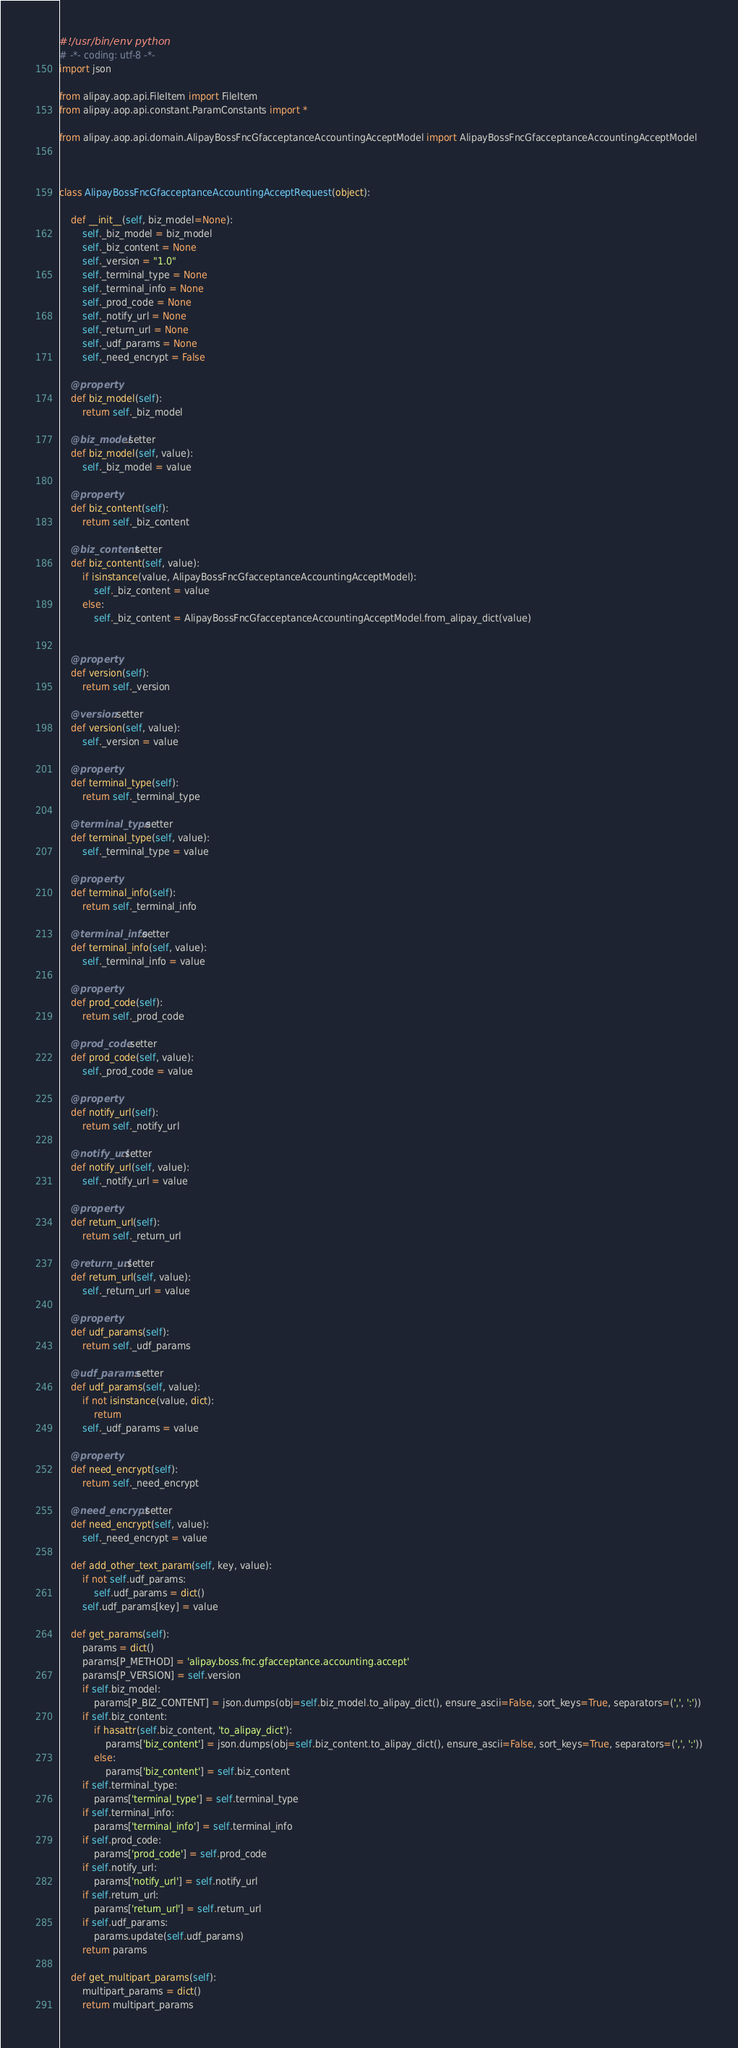Convert code to text. <code><loc_0><loc_0><loc_500><loc_500><_Python_>#!/usr/bin/env python
# -*- coding: utf-8 -*-
import json

from alipay.aop.api.FileItem import FileItem
from alipay.aop.api.constant.ParamConstants import *

from alipay.aop.api.domain.AlipayBossFncGfacceptanceAccountingAcceptModel import AlipayBossFncGfacceptanceAccountingAcceptModel



class AlipayBossFncGfacceptanceAccountingAcceptRequest(object):

    def __init__(self, biz_model=None):
        self._biz_model = biz_model
        self._biz_content = None
        self._version = "1.0"
        self._terminal_type = None
        self._terminal_info = None
        self._prod_code = None
        self._notify_url = None
        self._return_url = None
        self._udf_params = None
        self._need_encrypt = False

    @property
    def biz_model(self):
        return self._biz_model

    @biz_model.setter
    def biz_model(self, value):
        self._biz_model = value

    @property
    def biz_content(self):
        return self._biz_content

    @biz_content.setter
    def biz_content(self, value):
        if isinstance(value, AlipayBossFncGfacceptanceAccountingAcceptModel):
            self._biz_content = value
        else:
            self._biz_content = AlipayBossFncGfacceptanceAccountingAcceptModel.from_alipay_dict(value)


    @property
    def version(self):
        return self._version

    @version.setter
    def version(self, value):
        self._version = value

    @property
    def terminal_type(self):
        return self._terminal_type

    @terminal_type.setter
    def terminal_type(self, value):
        self._terminal_type = value

    @property
    def terminal_info(self):
        return self._terminal_info

    @terminal_info.setter
    def terminal_info(self, value):
        self._terminal_info = value

    @property
    def prod_code(self):
        return self._prod_code

    @prod_code.setter
    def prod_code(self, value):
        self._prod_code = value

    @property
    def notify_url(self):
        return self._notify_url

    @notify_url.setter
    def notify_url(self, value):
        self._notify_url = value

    @property
    def return_url(self):
        return self._return_url

    @return_url.setter
    def return_url(self, value):
        self._return_url = value

    @property
    def udf_params(self):
        return self._udf_params

    @udf_params.setter
    def udf_params(self, value):
        if not isinstance(value, dict):
            return
        self._udf_params = value

    @property
    def need_encrypt(self):
        return self._need_encrypt

    @need_encrypt.setter
    def need_encrypt(self, value):
        self._need_encrypt = value

    def add_other_text_param(self, key, value):
        if not self.udf_params:
            self.udf_params = dict()
        self.udf_params[key] = value

    def get_params(self):
        params = dict()
        params[P_METHOD] = 'alipay.boss.fnc.gfacceptance.accounting.accept'
        params[P_VERSION] = self.version
        if self.biz_model:
            params[P_BIZ_CONTENT] = json.dumps(obj=self.biz_model.to_alipay_dict(), ensure_ascii=False, sort_keys=True, separators=(',', ':'))
        if self.biz_content:
            if hasattr(self.biz_content, 'to_alipay_dict'):
                params['biz_content'] = json.dumps(obj=self.biz_content.to_alipay_dict(), ensure_ascii=False, sort_keys=True, separators=(',', ':'))
            else:
                params['biz_content'] = self.biz_content
        if self.terminal_type:
            params['terminal_type'] = self.terminal_type
        if self.terminal_info:
            params['terminal_info'] = self.terminal_info
        if self.prod_code:
            params['prod_code'] = self.prod_code
        if self.notify_url:
            params['notify_url'] = self.notify_url
        if self.return_url:
            params['return_url'] = self.return_url
        if self.udf_params:
            params.update(self.udf_params)
        return params

    def get_multipart_params(self):
        multipart_params = dict()
        return multipart_params
</code> 